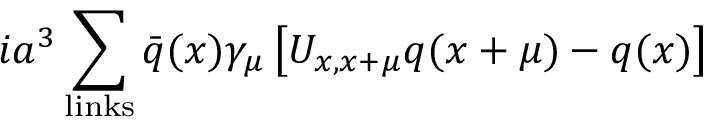Convert formula to latex. <formula><loc_0><loc_0><loc_500><loc_500>i a ^ { 3 } \sum _ { l i n k s } \bar { q } ( x ) \gamma _ { \mu } \left [ U _ { x , x + \mu } q ( x + \mu ) - q ( x ) \right ]</formula> 